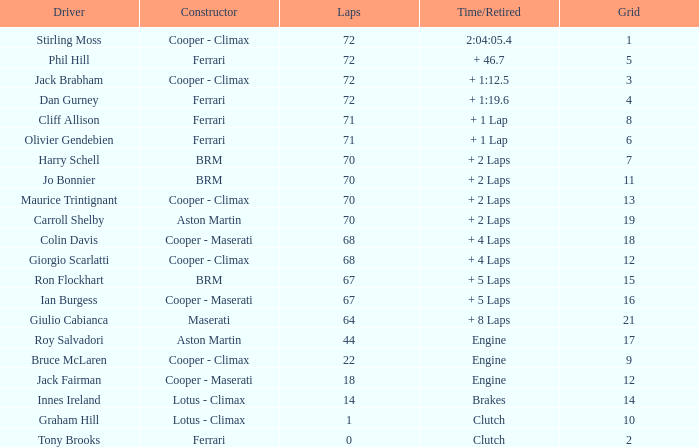What was phil hill's time/retirement when he completed more than 67 laps and had a grade lower than 18? + 46.7. 